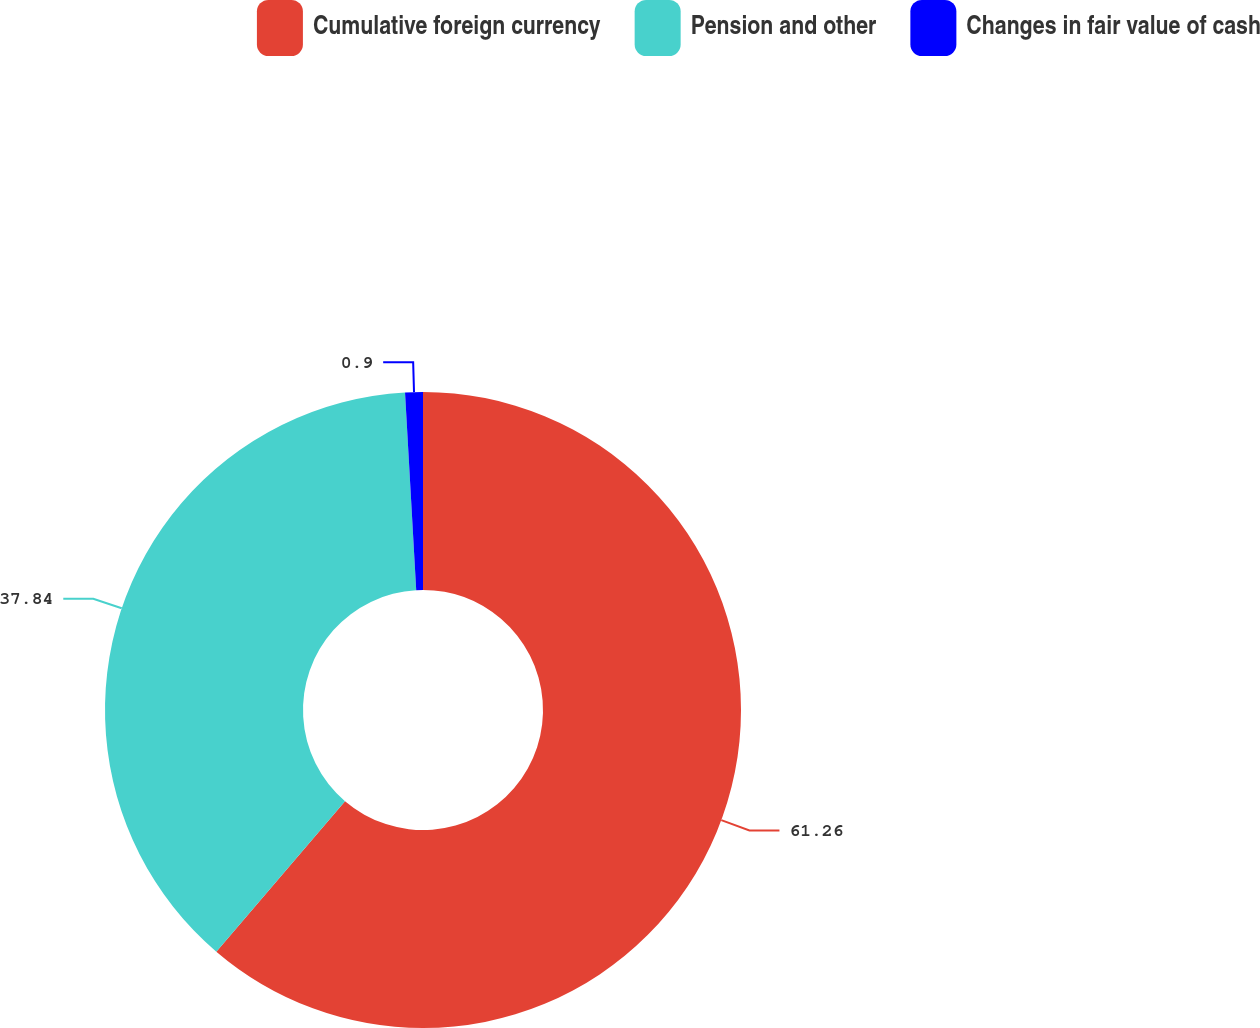Convert chart to OTSL. <chart><loc_0><loc_0><loc_500><loc_500><pie_chart><fcel>Cumulative foreign currency<fcel>Pension and other<fcel>Changes in fair value of cash<nl><fcel>61.26%<fcel>37.84%<fcel>0.9%<nl></chart> 